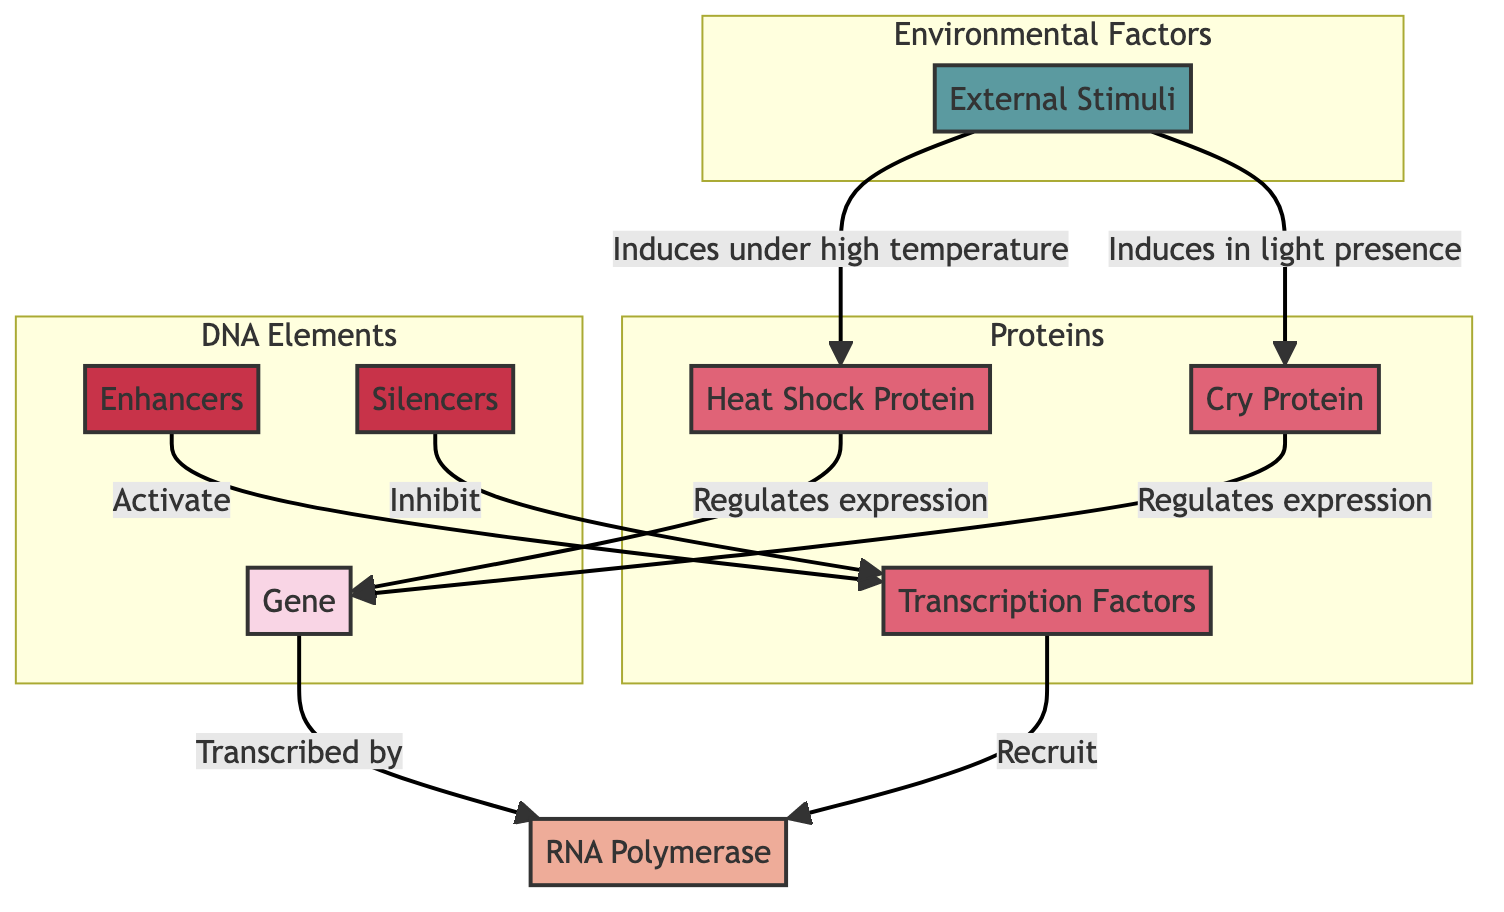What is the role of RNA Polymerase in the diagram? RNA Polymerase is transcribed by the gene, indicating that it plays a central role in the transcription process by synthesizing RNA from the DNA template.
Answer: Transcribed by gene How many proteins are shown in the diagram? The diagram features three proteins: Transcription Factors, Heat Shock Protein, and Cry Protein, making a total of three proteins.
Answer: Three Which element activates transcription factors? Enhancers activate transcription factors, providing signals that enhance the transcription of specific genes.
Answer: Enhancers What effect does high temperature have on gene expression in the diagram? High temperature induces the expression of the Heat Shock Protein, which then regulates gene expression, emphasizing the impact of environmental conditions on gene activity.
Answer: Induces Heat Shock Protein What happens when silencers are present in the diagram? Silencers inhibit transcription factors, which prevents them from activating the RNA Polymerase, thereby downregulating gene expression.
Answer: Inhibit transcription factors In the context of the diagram, what external stimulus influences the Cry Protein? Light presence is the external stimulus that induces the expression of the Cry Protein, which plays a role in regulating gene expression under specific environmental conditions.
Answer: Light presence Which two proteins are responsible for regulating gene expression? The Heat Shock Protein and Cry Protein are the two proteins that regulate gene expression in the context of the diagram, showing how gene expression can be influenced by different proteins.
Answer: Heat Shock Protein and Cry Protein How do transcription factors facilitate transcription based on the diagram? Transcription factors recruit RNA Polymerase, which is crucial for the transcription of DNA into RNA, indicating their vital role in initiating this process.
Answer: Recruit RNA Polymerase What are the three main subgraphs identified in the diagram? The three main subgraphs are DNA Elements, Proteins, and Environmental Factors, which categorize the components of the diagram into distinct functional groups.
Answer: DNA Elements, Proteins, Environmental Factors 